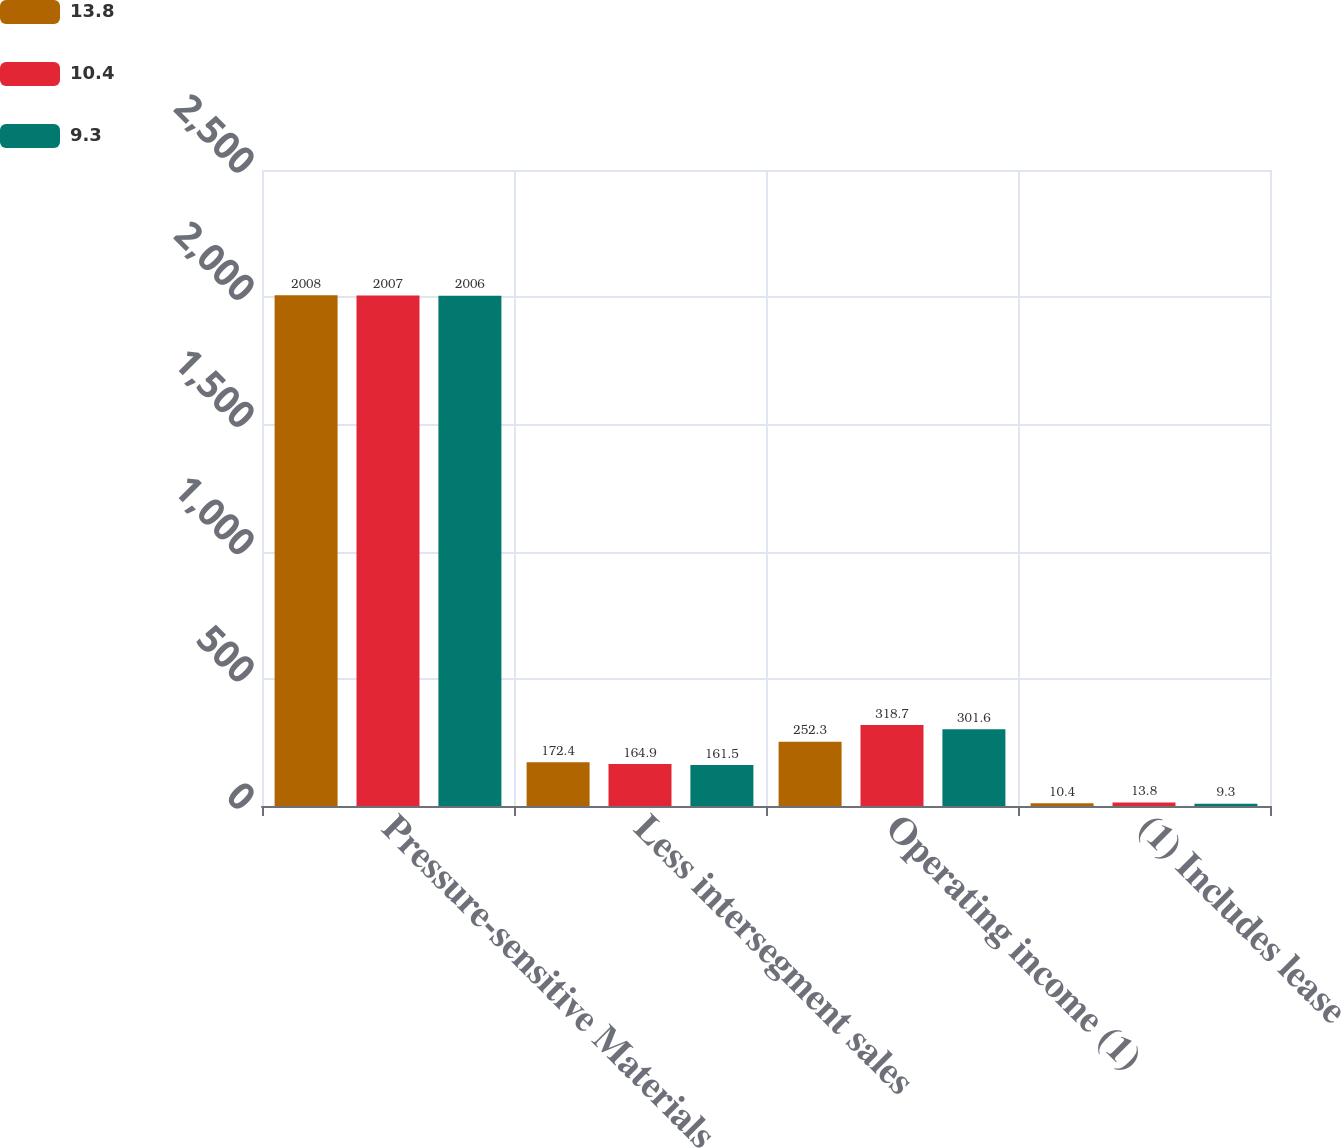<chart> <loc_0><loc_0><loc_500><loc_500><stacked_bar_chart><ecel><fcel>Pressure-sensitive Materials<fcel>Less intersegment sales<fcel>Operating income (1)<fcel>(1) Includes lease<nl><fcel>13.8<fcel>2008<fcel>172.4<fcel>252.3<fcel>10.4<nl><fcel>10.4<fcel>2007<fcel>164.9<fcel>318.7<fcel>13.8<nl><fcel>9.3<fcel>2006<fcel>161.5<fcel>301.6<fcel>9.3<nl></chart> 